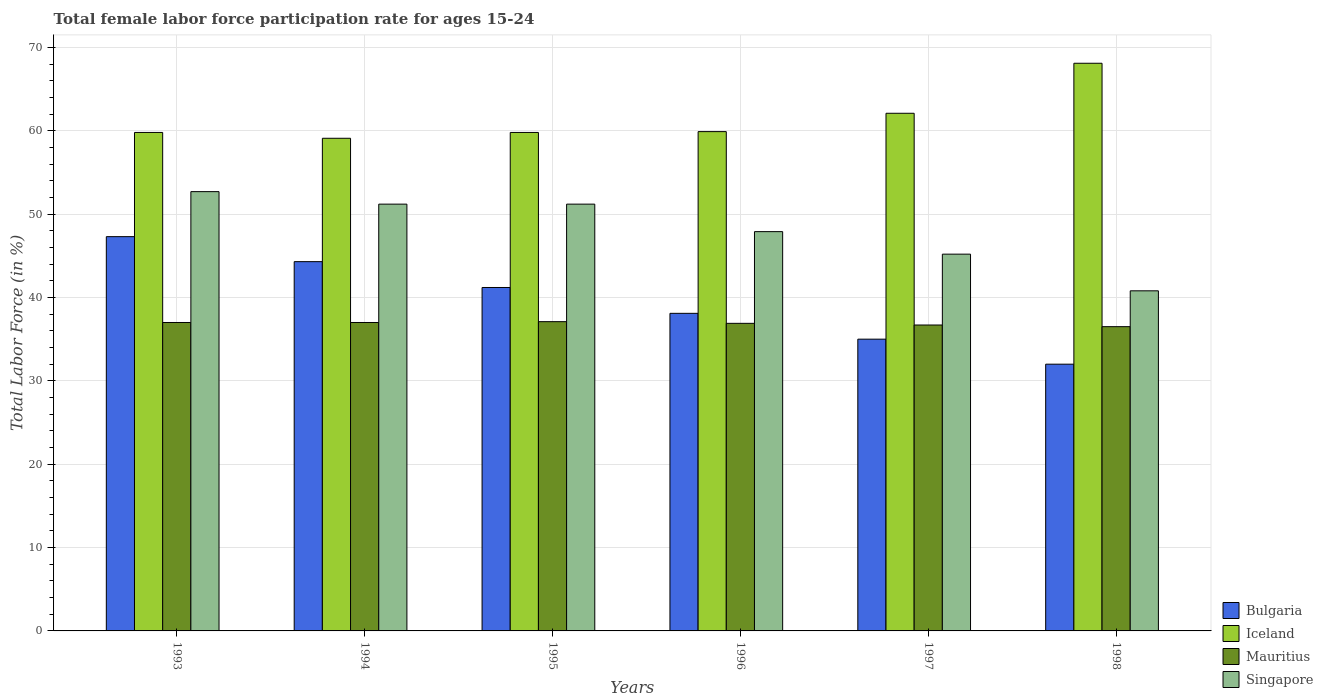How many groups of bars are there?
Your answer should be very brief. 6. Are the number of bars per tick equal to the number of legend labels?
Keep it short and to the point. Yes. How many bars are there on the 3rd tick from the right?
Provide a short and direct response. 4. In how many cases, is the number of bars for a given year not equal to the number of legend labels?
Keep it short and to the point. 0. What is the female labor force participation rate in Iceland in 1994?
Provide a short and direct response. 59.1. Across all years, what is the maximum female labor force participation rate in Mauritius?
Offer a very short reply. 37.1. Across all years, what is the minimum female labor force participation rate in Singapore?
Provide a short and direct response. 40.8. In which year was the female labor force participation rate in Bulgaria maximum?
Make the answer very short. 1993. What is the total female labor force participation rate in Mauritius in the graph?
Offer a terse response. 221.2. What is the difference between the female labor force participation rate in Mauritius in 1997 and that in 1998?
Make the answer very short. 0.2. What is the difference between the female labor force participation rate in Singapore in 1998 and the female labor force participation rate in Bulgaria in 1995?
Provide a succinct answer. -0.4. What is the average female labor force participation rate in Singapore per year?
Your answer should be very brief. 48.17. In the year 1995, what is the difference between the female labor force participation rate in Iceland and female labor force participation rate in Singapore?
Keep it short and to the point. 8.6. What is the ratio of the female labor force participation rate in Iceland in 1996 to that in 1998?
Keep it short and to the point. 0.88. What is the difference between the highest and the second highest female labor force participation rate in Mauritius?
Provide a short and direct response. 0.1. What is the difference between the highest and the lowest female labor force participation rate in Singapore?
Your answer should be compact. 11.9. In how many years, is the female labor force participation rate in Bulgaria greater than the average female labor force participation rate in Bulgaria taken over all years?
Your answer should be very brief. 3. Is the sum of the female labor force participation rate in Mauritius in 1993 and 1996 greater than the maximum female labor force participation rate in Singapore across all years?
Give a very brief answer. Yes. Is it the case that in every year, the sum of the female labor force participation rate in Bulgaria and female labor force participation rate in Iceland is greater than the female labor force participation rate in Singapore?
Make the answer very short. Yes. Are all the bars in the graph horizontal?
Give a very brief answer. No. How many years are there in the graph?
Keep it short and to the point. 6. Does the graph contain grids?
Offer a very short reply. Yes. How many legend labels are there?
Your response must be concise. 4. What is the title of the graph?
Ensure brevity in your answer.  Total female labor force participation rate for ages 15-24. What is the label or title of the X-axis?
Your response must be concise. Years. What is the Total Labor Force (in %) of Bulgaria in 1993?
Offer a terse response. 47.3. What is the Total Labor Force (in %) of Iceland in 1993?
Provide a short and direct response. 59.8. What is the Total Labor Force (in %) in Mauritius in 1993?
Give a very brief answer. 37. What is the Total Labor Force (in %) in Singapore in 1993?
Make the answer very short. 52.7. What is the Total Labor Force (in %) in Bulgaria in 1994?
Your response must be concise. 44.3. What is the Total Labor Force (in %) in Iceland in 1994?
Keep it short and to the point. 59.1. What is the Total Labor Force (in %) in Singapore in 1994?
Give a very brief answer. 51.2. What is the Total Labor Force (in %) of Bulgaria in 1995?
Your response must be concise. 41.2. What is the Total Labor Force (in %) of Iceland in 1995?
Provide a short and direct response. 59.8. What is the Total Labor Force (in %) in Mauritius in 1995?
Keep it short and to the point. 37.1. What is the Total Labor Force (in %) of Singapore in 1995?
Make the answer very short. 51.2. What is the Total Labor Force (in %) in Bulgaria in 1996?
Offer a very short reply. 38.1. What is the Total Labor Force (in %) of Iceland in 1996?
Ensure brevity in your answer.  59.9. What is the Total Labor Force (in %) in Mauritius in 1996?
Offer a terse response. 36.9. What is the Total Labor Force (in %) of Singapore in 1996?
Your response must be concise. 47.9. What is the Total Labor Force (in %) in Iceland in 1997?
Offer a very short reply. 62.1. What is the Total Labor Force (in %) of Mauritius in 1997?
Make the answer very short. 36.7. What is the Total Labor Force (in %) of Singapore in 1997?
Provide a succinct answer. 45.2. What is the Total Labor Force (in %) in Bulgaria in 1998?
Your answer should be compact. 32. What is the Total Labor Force (in %) in Iceland in 1998?
Your answer should be very brief. 68.1. What is the Total Labor Force (in %) of Mauritius in 1998?
Your answer should be compact. 36.5. What is the Total Labor Force (in %) in Singapore in 1998?
Provide a short and direct response. 40.8. Across all years, what is the maximum Total Labor Force (in %) of Bulgaria?
Your answer should be very brief. 47.3. Across all years, what is the maximum Total Labor Force (in %) of Iceland?
Keep it short and to the point. 68.1. Across all years, what is the maximum Total Labor Force (in %) of Mauritius?
Your answer should be compact. 37.1. Across all years, what is the maximum Total Labor Force (in %) in Singapore?
Provide a succinct answer. 52.7. Across all years, what is the minimum Total Labor Force (in %) of Bulgaria?
Offer a very short reply. 32. Across all years, what is the minimum Total Labor Force (in %) in Iceland?
Provide a short and direct response. 59.1. Across all years, what is the minimum Total Labor Force (in %) of Mauritius?
Your response must be concise. 36.5. Across all years, what is the minimum Total Labor Force (in %) in Singapore?
Make the answer very short. 40.8. What is the total Total Labor Force (in %) in Bulgaria in the graph?
Ensure brevity in your answer.  237.9. What is the total Total Labor Force (in %) in Iceland in the graph?
Your answer should be very brief. 368.8. What is the total Total Labor Force (in %) in Mauritius in the graph?
Provide a short and direct response. 221.2. What is the total Total Labor Force (in %) in Singapore in the graph?
Your answer should be compact. 289. What is the difference between the Total Labor Force (in %) in Iceland in 1993 and that in 1994?
Your response must be concise. 0.7. What is the difference between the Total Labor Force (in %) of Iceland in 1993 and that in 1996?
Offer a terse response. -0.1. What is the difference between the Total Labor Force (in %) in Bulgaria in 1993 and that in 1997?
Your answer should be very brief. 12.3. What is the difference between the Total Labor Force (in %) of Iceland in 1993 and that in 1997?
Your answer should be compact. -2.3. What is the difference between the Total Labor Force (in %) of Mauritius in 1993 and that in 1997?
Your response must be concise. 0.3. What is the difference between the Total Labor Force (in %) in Iceland in 1993 and that in 1998?
Your answer should be compact. -8.3. What is the difference between the Total Labor Force (in %) in Mauritius in 1993 and that in 1998?
Provide a short and direct response. 0.5. What is the difference between the Total Labor Force (in %) of Bulgaria in 1994 and that in 1995?
Keep it short and to the point. 3.1. What is the difference between the Total Labor Force (in %) of Iceland in 1994 and that in 1995?
Offer a very short reply. -0.7. What is the difference between the Total Labor Force (in %) in Mauritius in 1994 and that in 1995?
Offer a terse response. -0.1. What is the difference between the Total Labor Force (in %) of Bulgaria in 1994 and that in 1996?
Your response must be concise. 6.2. What is the difference between the Total Labor Force (in %) in Iceland in 1994 and that in 1996?
Provide a short and direct response. -0.8. What is the difference between the Total Labor Force (in %) of Iceland in 1994 and that in 1997?
Your response must be concise. -3. What is the difference between the Total Labor Force (in %) in Iceland in 1994 and that in 1998?
Provide a short and direct response. -9. What is the difference between the Total Labor Force (in %) in Mauritius in 1994 and that in 1998?
Your answer should be compact. 0.5. What is the difference between the Total Labor Force (in %) in Bulgaria in 1995 and that in 1996?
Keep it short and to the point. 3.1. What is the difference between the Total Labor Force (in %) in Mauritius in 1995 and that in 1996?
Your response must be concise. 0.2. What is the difference between the Total Labor Force (in %) of Singapore in 1995 and that in 1996?
Your answer should be very brief. 3.3. What is the difference between the Total Labor Force (in %) in Singapore in 1995 and that in 1997?
Keep it short and to the point. 6. What is the difference between the Total Labor Force (in %) of Singapore in 1995 and that in 1998?
Offer a very short reply. 10.4. What is the difference between the Total Labor Force (in %) of Bulgaria in 1996 and that in 1997?
Your answer should be very brief. 3.1. What is the difference between the Total Labor Force (in %) in Mauritius in 1996 and that in 1997?
Your answer should be very brief. 0.2. What is the difference between the Total Labor Force (in %) of Singapore in 1996 and that in 1997?
Ensure brevity in your answer.  2.7. What is the difference between the Total Labor Force (in %) of Bulgaria in 1996 and that in 1998?
Offer a terse response. 6.1. What is the difference between the Total Labor Force (in %) of Singapore in 1996 and that in 1998?
Your answer should be very brief. 7.1. What is the difference between the Total Labor Force (in %) of Bulgaria in 1997 and that in 1998?
Your response must be concise. 3. What is the difference between the Total Labor Force (in %) in Mauritius in 1997 and that in 1998?
Ensure brevity in your answer.  0.2. What is the difference between the Total Labor Force (in %) in Singapore in 1997 and that in 1998?
Provide a short and direct response. 4.4. What is the difference between the Total Labor Force (in %) in Bulgaria in 1993 and the Total Labor Force (in %) in Singapore in 1994?
Provide a short and direct response. -3.9. What is the difference between the Total Labor Force (in %) of Iceland in 1993 and the Total Labor Force (in %) of Mauritius in 1994?
Provide a succinct answer. 22.8. What is the difference between the Total Labor Force (in %) in Iceland in 1993 and the Total Labor Force (in %) in Singapore in 1994?
Provide a short and direct response. 8.6. What is the difference between the Total Labor Force (in %) in Mauritius in 1993 and the Total Labor Force (in %) in Singapore in 1994?
Keep it short and to the point. -14.2. What is the difference between the Total Labor Force (in %) of Bulgaria in 1993 and the Total Labor Force (in %) of Iceland in 1995?
Offer a terse response. -12.5. What is the difference between the Total Labor Force (in %) of Bulgaria in 1993 and the Total Labor Force (in %) of Mauritius in 1995?
Your answer should be very brief. 10.2. What is the difference between the Total Labor Force (in %) of Iceland in 1993 and the Total Labor Force (in %) of Mauritius in 1995?
Ensure brevity in your answer.  22.7. What is the difference between the Total Labor Force (in %) of Iceland in 1993 and the Total Labor Force (in %) of Singapore in 1995?
Offer a very short reply. 8.6. What is the difference between the Total Labor Force (in %) of Bulgaria in 1993 and the Total Labor Force (in %) of Iceland in 1996?
Provide a succinct answer. -12.6. What is the difference between the Total Labor Force (in %) in Bulgaria in 1993 and the Total Labor Force (in %) in Singapore in 1996?
Provide a succinct answer. -0.6. What is the difference between the Total Labor Force (in %) of Iceland in 1993 and the Total Labor Force (in %) of Mauritius in 1996?
Keep it short and to the point. 22.9. What is the difference between the Total Labor Force (in %) of Bulgaria in 1993 and the Total Labor Force (in %) of Iceland in 1997?
Offer a very short reply. -14.8. What is the difference between the Total Labor Force (in %) in Bulgaria in 1993 and the Total Labor Force (in %) in Singapore in 1997?
Provide a short and direct response. 2.1. What is the difference between the Total Labor Force (in %) of Iceland in 1993 and the Total Labor Force (in %) of Mauritius in 1997?
Offer a terse response. 23.1. What is the difference between the Total Labor Force (in %) in Iceland in 1993 and the Total Labor Force (in %) in Singapore in 1997?
Your response must be concise. 14.6. What is the difference between the Total Labor Force (in %) of Bulgaria in 1993 and the Total Labor Force (in %) of Iceland in 1998?
Provide a succinct answer. -20.8. What is the difference between the Total Labor Force (in %) of Iceland in 1993 and the Total Labor Force (in %) of Mauritius in 1998?
Your answer should be compact. 23.3. What is the difference between the Total Labor Force (in %) of Iceland in 1993 and the Total Labor Force (in %) of Singapore in 1998?
Make the answer very short. 19. What is the difference between the Total Labor Force (in %) in Mauritius in 1993 and the Total Labor Force (in %) in Singapore in 1998?
Ensure brevity in your answer.  -3.8. What is the difference between the Total Labor Force (in %) of Bulgaria in 1994 and the Total Labor Force (in %) of Iceland in 1995?
Your answer should be compact. -15.5. What is the difference between the Total Labor Force (in %) in Bulgaria in 1994 and the Total Labor Force (in %) in Mauritius in 1995?
Keep it short and to the point. 7.2. What is the difference between the Total Labor Force (in %) in Bulgaria in 1994 and the Total Labor Force (in %) in Singapore in 1995?
Make the answer very short. -6.9. What is the difference between the Total Labor Force (in %) of Iceland in 1994 and the Total Labor Force (in %) of Mauritius in 1995?
Your response must be concise. 22. What is the difference between the Total Labor Force (in %) in Bulgaria in 1994 and the Total Labor Force (in %) in Iceland in 1996?
Make the answer very short. -15.6. What is the difference between the Total Labor Force (in %) in Bulgaria in 1994 and the Total Labor Force (in %) in Mauritius in 1996?
Provide a short and direct response. 7.4. What is the difference between the Total Labor Force (in %) in Bulgaria in 1994 and the Total Labor Force (in %) in Singapore in 1996?
Ensure brevity in your answer.  -3.6. What is the difference between the Total Labor Force (in %) in Iceland in 1994 and the Total Labor Force (in %) in Singapore in 1996?
Your answer should be very brief. 11.2. What is the difference between the Total Labor Force (in %) in Bulgaria in 1994 and the Total Labor Force (in %) in Iceland in 1997?
Make the answer very short. -17.8. What is the difference between the Total Labor Force (in %) in Iceland in 1994 and the Total Labor Force (in %) in Mauritius in 1997?
Give a very brief answer. 22.4. What is the difference between the Total Labor Force (in %) of Iceland in 1994 and the Total Labor Force (in %) of Singapore in 1997?
Offer a very short reply. 13.9. What is the difference between the Total Labor Force (in %) of Mauritius in 1994 and the Total Labor Force (in %) of Singapore in 1997?
Ensure brevity in your answer.  -8.2. What is the difference between the Total Labor Force (in %) in Bulgaria in 1994 and the Total Labor Force (in %) in Iceland in 1998?
Offer a terse response. -23.8. What is the difference between the Total Labor Force (in %) in Bulgaria in 1994 and the Total Labor Force (in %) in Singapore in 1998?
Provide a short and direct response. 3.5. What is the difference between the Total Labor Force (in %) in Iceland in 1994 and the Total Labor Force (in %) in Mauritius in 1998?
Keep it short and to the point. 22.6. What is the difference between the Total Labor Force (in %) in Bulgaria in 1995 and the Total Labor Force (in %) in Iceland in 1996?
Give a very brief answer. -18.7. What is the difference between the Total Labor Force (in %) in Bulgaria in 1995 and the Total Labor Force (in %) in Singapore in 1996?
Provide a succinct answer. -6.7. What is the difference between the Total Labor Force (in %) in Iceland in 1995 and the Total Labor Force (in %) in Mauritius in 1996?
Make the answer very short. 22.9. What is the difference between the Total Labor Force (in %) in Iceland in 1995 and the Total Labor Force (in %) in Singapore in 1996?
Make the answer very short. 11.9. What is the difference between the Total Labor Force (in %) in Bulgaria in 1995 and the Total Labor Force (in %) in Iceland in 1997?
Provide a succinct answer. -20.9. What is the difference between the Total Labor Force (in %) in Bulgaria in 1995 and the Total Labor Force (in %) in Mauritius in 1997?
Provide a short and direct response. 4.5. What is the difference between the Total Labor Force (in %) in Bulgaria in 1995 and the Total Labor Force (in %) in Singapore in 1997?
Offer a very short reply. -4. What is the difference between the Total Labor Force (in %) in Iceland in 1995 and the Total Labor Force (in %) in Mauritius in 1997?
Provide a succinct answer. 23.1. What is the difference between the Total Labor Force (in %) in Bulgaria in 1995 and the Total Labor Force (in %) in Iceland in 1998?
Offer a terse response. -26.9. What is the difference between the Total Labor Force (in %) in Bulgaria in 1995 and the Total Labor Force (in %) in Mauritius in 1998?
Ensure brevity in your answer.  4.7. What is the difference between the Total Labor Force (in %) of Bulgaria in 1995 and the Total Labor Force (in %) of Singapore in 1998?
Give a very brief answer. 0.4. What is the difference between the Total Labor Force (in %) of Iceland in 1995 and the Total Labor Force (in %) of Mauritius in 1998?
Your answer should be compact. 23.3. What is the difference between the Total Labor Force (in %) in Iceland in 1995 and the Total Labor Force (in %) in Singapore in 1998?
Make the answer very short. 19. What is the difference between the Total Labor Force (in %) in Mauritius in 1995 and the Total Labor Force (in %) in Singapore in 1998?
Your answer should be very brief. -3.7. What is the difference between the Total Labor Force (in %) in Bulgaria in 1996 and the Total Labor Force (in %) in Iceland in 1997?
Your answer should be compact. -24. What is the difference between the Total Labor Force (in %) in Bulgaria in 1996 and the Total Labor Force (in %) in Singapore in 1997?
Your response must be concise. -7.1. What is the difference between the Total Labor Force (in %) of Iceland in 1996 and the Total Labor Force (in %) of Mauritius in 1997?
Keep it short and to the point. 23.2. What is the difference between the Total Labor Force (in %) of Bulgaria in 1996 and the Total Labor Force (in %) of Iceland in 1998?
Your answer should be very brief. -30. What is the difference between the Total Labor Force (in %) of Bulgaria in 1996 and the Total Labor Force (in %) of Singapore in 1998?
Provide a short and direct response. -2.7. What is the difference between the Total Labor Force (in %) in Iceland in 1996 and the Total Labor Force (in %) in Mauritius in 1998?
Your response must be concise. 23.4. What is the difference between the Total Labor Force (in %) of Iceland in 1996 and the Total Labor Force (in %) of Singapore in 1998?
Give a very brief answer. 19.1. What is the difference between the Total Labor Force (in %) in Bulgaria in 1997 and the Total Labor Force (in %) in Iceland in 1998?
Make the answer very short. -33.1. What is the difference between the Total Labor Force (in %) in Iceland in 1997 and the Total Labor Force (in %) in Mauritius in 1998?
Your response must be concise. 25.6. What is the difference between the Total Labor Force (in %) in Iceland in 1997 and the Total Labor Force (in %) in Singapore in 1998?
Give a very brief answer. 21.3. What is the difference between the Total Labor Force (in %) of Mauritius in 1997 and the Total Labor Force (in %) of Singapore in 1998?
Offer a terse response. -4.1. What is the average Total Labor Force (in %) of Bulgaria per year?
Give a very brief answer. 39.65. What is the average Total Labor Force (in %) in Iceland per year?
Offer a terse response. 61.47. What is the average Total Labor Force (in %) of Mauritius per year?
Ensure brevity in your answer.  36.87. What is the average Total Labor Force (in %) of Singapore per year?
Your response must be concise. 48.17. In the year 1993, what is the difference between the Total Labor Force (in %) in Bulgaria and Total Labor Force (in %) in Iceland?
Offer a terse response. -12.5. In the year 1993, what is the difference between the Total Labor Force (in %) of Bulgaria and Total Labor Force (in %) of Singapore?
Offer a very short reply. -5.4. In the year 1993, what is the difference between the Total Labor Force (in %) of Iceland and Total Labor Force (in %) of Mauritius?
Offer a terse response. 22.8. In the year 1993, what is the difference between the Total Labor Force (in %) of Iceland and Total Labor Force (in %) of Singapore?
Your response must be concise. 7.1. In the year 1993, what is the difference between the Total Labor Force (in %) of Mauritius and Total Labor Force (in %) of Singapore?
Your response must be concise. -15.7. In the year 1994, what is the difference between the Total Labor Force (in %) of Bulgaria and Total Labor Force (in %) of Iceland?
Keep it short and to the point. -14.8. In the year 1994, what is the difference between the Total Labor Force (in %) in Iceland and Total Labor Force (in %) in Mauritius?
Your answer should be compact. 22.1. In the year 1994, what is the difference between the Total Labor Force (in %) in Mauritius and Total Labor Force (in %) in Singapore?
Provide a succinct answer. -14.2. In the year 1995, what is the difference between the Total Labor Force (in %) of Bulgaria and Total Labor Force (in %) of Iceland?
Your answer should be compact. -18.6. In the year 1995, what is the difference between the Total Labor Force (in %) in Iceland and Total Labor Force (in %) in Mauritius?
Ensure brevity in your answer.  22.7. In the year 1995, what is the difference between the Total Labor Force (in %) of Mauritius and Total Labor Force (in %) of Singapore?
Provide a succinct answer. -14.1. In the year 1996, what is the difference between the Total Labor Force (in %) in Bulgaria and Total Labor Force (in %) in Iceland?
Your answer should be compact. -21.8. In the year 1996, what is the difference between the Total Labor Force (in %) of Bulgaria and Total Labor Force (in %) of Mauritius?
Provide a short and direct response. 1.2. In the year 1996, what is the difference between the Total Labor Force (in %) of Iceland and Total Labor Force (in %) of Mauritius?
Give a very brief answer. 23. In the year 1997, what is the difference between the Total Labor Force (in %) of Bulgaria and Total Labor Force (in %) of Iceland?
Ensure brevity in your answer.  -27.1. In the year 1997, what is the difference between the Total Labor Force (in %) of Bulgaria and Total Labor Force (in %) of Mauritius?
Your answer should be compact. -1.7. In the year 1997, what is the difference between the Total Labor Force (in %) in Bulgaria and Total Labor Force (in %) in Singapore?
Ensure brevity in your answer.  -10.2. In the year 1997, what is the difference between the Total Labor Force (in %) in Iceland and Total Labor Force (in %) in Mauritius?
Provide a short and direct response. 25.4. In the year 1997, what is the difference between the Total Labor Force (in %) in Iceland and Total Labor Force (in %) in Singapore?
Provide a short and direct response. 16.9. In the year 1997, what is the difference between the Total Labor Force (in %) in Mauritius and Total Labor Force (in %) in Singapore?
Keep it short and to the point. -8.5. In the year 1998, what is the difference between the Total Labor Force (in %) of Bulgaria and Total Labor Force (in %) of Iceland?
Offer a terse response. -36.1. In the year 1998, what is the difference between the Total Labor Force (in %) of Bulgaria and Total Labor Force (in %) of Singapore?
Your answer should be compact. -8.8. In the year 1998, what is the difference between the Total Labor Force (in %) of Iceland and Total Labor Force (in %) of Mauritius?
Keep it short and to the point. 31.6. In the year 1998, what is the difference between the Total Labor Force (in %) in Iceland and Total Labor Force (in %) in Singapore?
Offer a terse response. 27.3. What is the ratio of the Total Labor Force (in %) of Bulgaria in 1993 to that in 1994?
Offer a terse response. 1.07. What is the ratio of the Total Labor Force (in %) of Iceland in 1993 to that in 1994?
Provide a succinct answer. 1.01. What is the ratio of the Total Labor Force (in %) of Mauritius in 1993 to that in 1994?
Offer a very short reply. 1. What is the ratio of the Total Labor Force (in %) of Singapore in 1993 to that in 1994?
Make the answer very short. 1.03. What is the ratio of the Total Labor Force (in %) of Bulgaria in 1993 to that in 1995?
Your answer should be very brief. 1.15. What is the ratio of the Total Labor Force (in %) in Iceland in 1993 to that in 1995?
Make the answer very short. 1. What is the ratio of the Total Labor Force (in %) in Mauritius in 1993 to that in 1995?
Offer a very short reply. 1. What is the ratio of the Total Labor Force (in %) of Singapore in 1993 to that in 1995?
Give a very brief answer. 1.03. What is the ratio of the Total Labor Force (in %) in Bulgaria in 1993 to that in 1996?
Give a very brief answer. 1.24. What is the ratio of the Total Labor Force (in %) in Singapore in 1993 to that in 1996?
Offer a very short reply. 1.1. What is the ratio of the Total Labor Force (in %) in Bulgaria in 1993 to that in 1997?
Your answer should be compact. 1.35. What is the ratio of the Total Labor Force (in %) in Iceland in 1993 to that in 1997?
Keep it short and to the point. 0.96. What is the ratio of the Total Labor Force (in %) in Mauritius in 1993 to that in 1997?
Your response must be concise. 1.01. What is the ratio of the Total Labor Force (in %) in Singapore in 1993 to that in 1997?
Give a very brief answer. 1.17. What is the ratio of the Total Labor Force (in %) of Bulgaria in 1993 to that in 1998?
Give a very brief answer. 1.48. What is the ratio of the Total Labor Force (in %) of Iceland in 1993 to that in 1998?
Offer a very short reply. 0.88. What is the ratio of the Total Labor Force (in %) in Mauritius in 1993 to that in 1998?
Provide a succinct answer. 1.01. What is the ratio of the Total Labor Force (in %) in Singapore in 1993 to that in 1998?
Provide a succinct answer. 1.29. What is the ratio of the Total Labor Force (in %) in Bulgaria in 1994 to that in 1995?
Your answer should be compact. 1.08. What is the ratio of the Total Labor Force (in %) in Iceland in 1994 to that in 1995?
Provide a short and direct response. 0.99. What is the ratio of the Total Labor Force (in %) of Singapore in 1994 to that in 1995?
Your answer should be very brief. 1. What is the ratio of the Total Labor Force (in %) in Bulgaria in 1994 to that in 1996?
Give a very brief answer. 1.16. What is the ratio of the Total Labor Force (in %) in Iceland in 1994 to that in 1996?
Offer a very short reply. 0.99. What is the ratio of the Total Labor Force (in %) in Singapore in 1994 to that in 1996?
Your answer should be compact. 1.07. What is the ratio of the Total Labor Force (in %) of Bulgaria in 1994 to that in 1997?
Provide a succinct answer. 1.27. What is the ratio of the Total Labor Force (in %) of Iceland in 1994 to that in 1997?
Keep it short and to the point. 0.95. What is the ratio of the Total Labor Force (in %) in Mauritius in 1994 to that in 1997?
Offer a terse response. 1.01. What is the ratio of the Total Labor Force (in %) of Singapore in 1994 to that in 1997?
Offer a very short reply. 1.13. What is the ratio of the Total Labor Force (in %) of Bulgaria in 1994 to that in 1998?
Your answer should be very brief. 1.38. What is the ratio of the Total Labor Force (in %) in Iceland in 1994 to that in 1998?
Make the answer very short. 0.87. What is the ratio of the Total Labor Force (in %) of Mauritius in 1994 to that in 1998?
Offer a terse response. 1.01. What is the ratio of the Total Labor Force (in %) in Singapore in 1994 to that in 1998?
Provide a short and direct response. 1.25. What is the ratio of the Total Labor Force (in %) in Bulgaria in 1995 to that in 1996?
Your response must be concise. 1.08. What is the ratio of the Total Labor Force (in %) in Iceland in 1995 to that in 1996?
Offer a very short reply. 1. What is the ratio of the Total Labor Force (in %) of Mauritius in 1995 to that in 1996?
Your answer should be very brief. 1.01. What is the ratio of the Total Labor Force (in %) of Singapore in 1995 to that in 1996?
Give a very brief answer. 1.07. What is the ratio of the Total Labor Force (in %) of Bulgaria in 1995 to that in 1997?
Offer a terse response. 1.18. What is the ratio of the Total Labor Force (in %) of Mauritius in 1995 to that in 1997?
Your answer should be compact. 1.01. What is the ratio of the Total Labor Force (in %) of Singapore in 1995 to that in 1997?
Keep it short and to the point. 1.13. What is the ratio of the Total Labor Force (in %) of Bulgaria in 1995 to that in 1998?
Provide a short and direct response. 1.29. What is the ratio of the Total Labor Force (in %) in Iceland in 1995 to that in 1998?
Provide a short and direct response. 0.88. What is the ratio of the Total Labor Force (in %) in Mauritius in 1995 to that in 1998?
Your response must be concise. 1.02. What is the ratio of the Total Labor Force (in %) in Singapore in 1995 to that in 1998?
Offer a terse response. 1.25. What is the ratio of the Total Labor Force (in %) of Bulgaria in 1996 to that in 1997?
Provide a short and direct response. 1.09. What is the ratio of the Total Labor Force (in %) in Iceland in 1996 to that in 1997?
Provide a short and direct response. 0.96. What is the ratio of the Total Labor Force (in %) in Mauritius in 1996 to that in 1997?
Your answer should be compact. 1.01. What is the ratio of the Total Labor Force (in %) in Singapore in 1996 to that in 1997?
Your answer should be compact. 1.06. What is the ratio of the Total Labor Force (in %) of Bulgaria in 1996 to that in 1998?
Ensure brevity in your answer.  1.19. What is the ratio of the Total Labor Force (in %) in Iceland in 1996 to that in 1998?
Ensure brevity in your answer.  0.88. What is the ratio of the Total Labor Force (in %) of Mauritius in 1996 to that in 1998?
Ensure brevity in your answer.  1.01. What is the ratio of the Total Labor Force (in %) in Singapore in 1996 to that in 1998?
Offer a very short reply. 1.17. What is the ratio of the Total Labor Force (in %) of Bulgaria in 1997 to that in 1998?
Ensure brevity in your answer.  1.09. What is the ratio of the Total Labor Force (in %) of Iceland in 1997 to that in 1998?
Make the answer very short. 0.91. What is the ratio of the Total Labor Force (in %) of Mauritius in 1997 to that in 1998?
Provide a succinct answer. 1.01. What is the ratio of the Total Labor Force (in %) of Singapore in 1997 to that in 1998?
Keep it short and to the point. 1.11. What is the difference between the highest and the second highest Total Labor Force (in %) of Bulgaria?
Your answer should be compact. 3. What is the difference between the highest and the second highest Total Labor Force (in %) of Iceland?
Keep it short and to the point. 6. What is the difference between the highest and the second highest Total Labor Force (in %) of Singapore?
Your answer should be very brief. 1.5. What is the difference between the highest and the lowest Total Labor Force (in %) of Bulgaria?
Your response must be concise. 15.3. What is the difference between the highest and the lowest Total Labor Force (in %) of Iceland?
Provide a short and direct response. 9. What is the difference between the highest and the lowest Total Labor Force (in %) of Mauritius?
Offer a very short reply. 0.6. What is the difference between the highest and the lowest Total Labor Force (in %) in Singapore?
Ensure brevity in your answer.  11.9. 